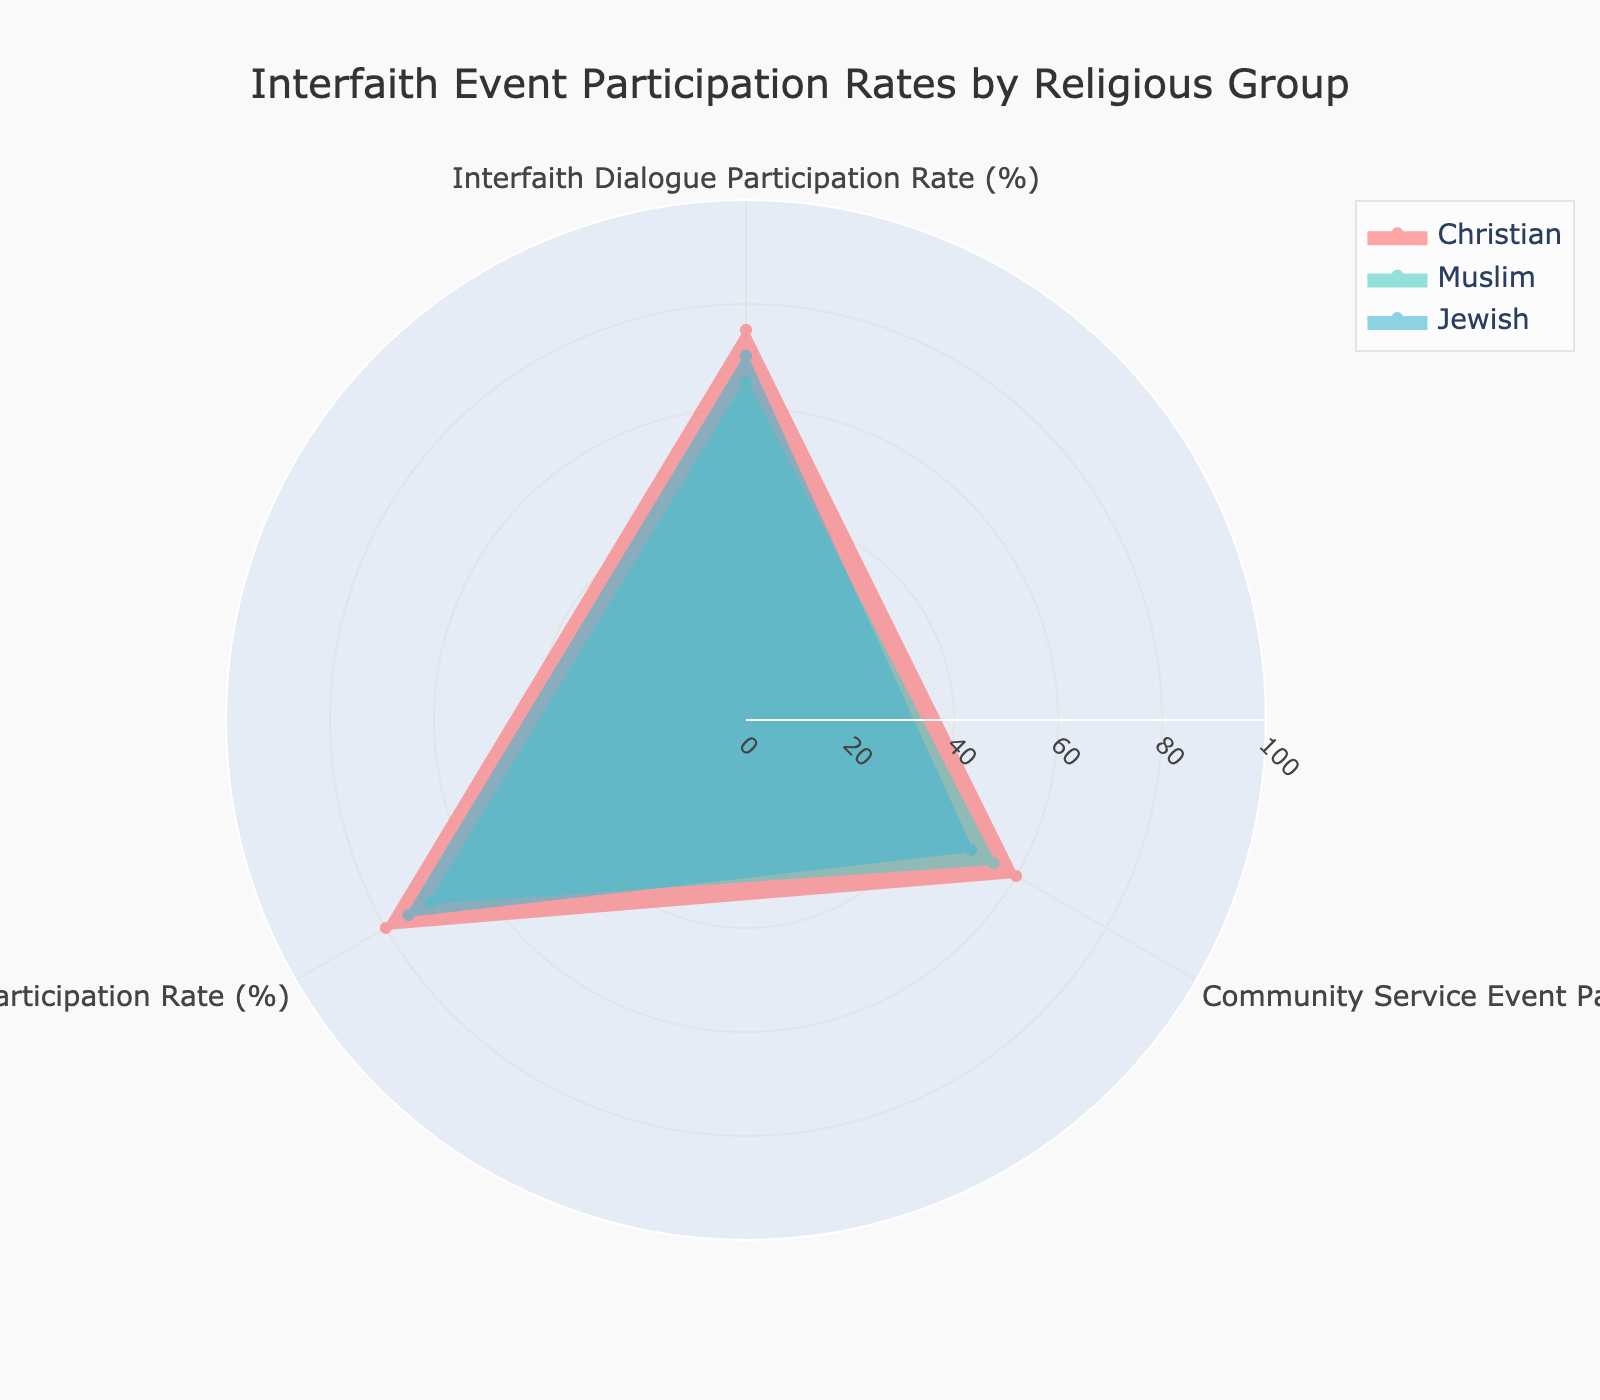What is the title of the figure? The title is usually displayed at the top of the chart, and in this case, it is clearly stated in the plot settings.
Answer: Interfaith Event Participation Rates by Religious Group How many religious groups are represented in the radar chart? By counting the different groups mentioned in the legend, we can determine that there are three represented groups.
Answer: Three Which religious group has the highest Interfaith Dialogue Participation Rate? By comparing the radial values for the category "Interfaith Dialogue Participation Rate" for each group, we see the highest value is 75%, which belongs to the Christian group.
Answer: Christian What is the average Interfaith Dialogue Participation Rate across all religious groups shown? First, sum the Interfaith Dialogue Participation Rates for Christian (75), Muslim (65), and Jewish (70), giving us 210. Then, divide by the number of groups (3), resulting in an average of 70%.
Answer: 70% Which religious group participates less in Community Service Events compared to others? Comparing the values for Community Service Event Participation Rates, the Jewish group has the lowest rate at 50%.
Answer: Jewish How does the Community Service Event Participation Rate of Muslims compare to that of Christians? The Community Service Event Participation Rate for Muslims is 55%, while for Christians it is 60%. Thus, Muslims have a 5% lower participation rate compared to Christians.
Answer: Muslims have a 5% lower participation rate Which participation rate category shows the most variation among the religious groups? By comparing the ranges of participation rates for each category: Interfaith Dialogue (75-65=10), Community Service (60-50=10), Cultural Exchange (80-70=10), all categories show similar variations of 10%.
Answer: All categories are equal What is the combined participation rate for the Jewish group across all categories? Sum the participation rates for the Jewish group: Interfaith Dialogue (70), Community Service (50), and Cultural Exchange (75), resulting in a combined rate of 70 + 50 + 75 = 195.
Answer: 195% Which religious group has the closest values across all participation categories? By observing the values, we see that the Christian group has participation rates of 75%, 60%, and 80%, making their values the closest compared to the other groups.
Answer: Christian What is the difference in participation in Cultural Exchange Programs between Christians and Muslims? The Cultural Exchange Program Participation Rate for Christians is 80%, while for Muslims it is 70%. The difference is 80 - 70 = 10%.
Answer: 10% 